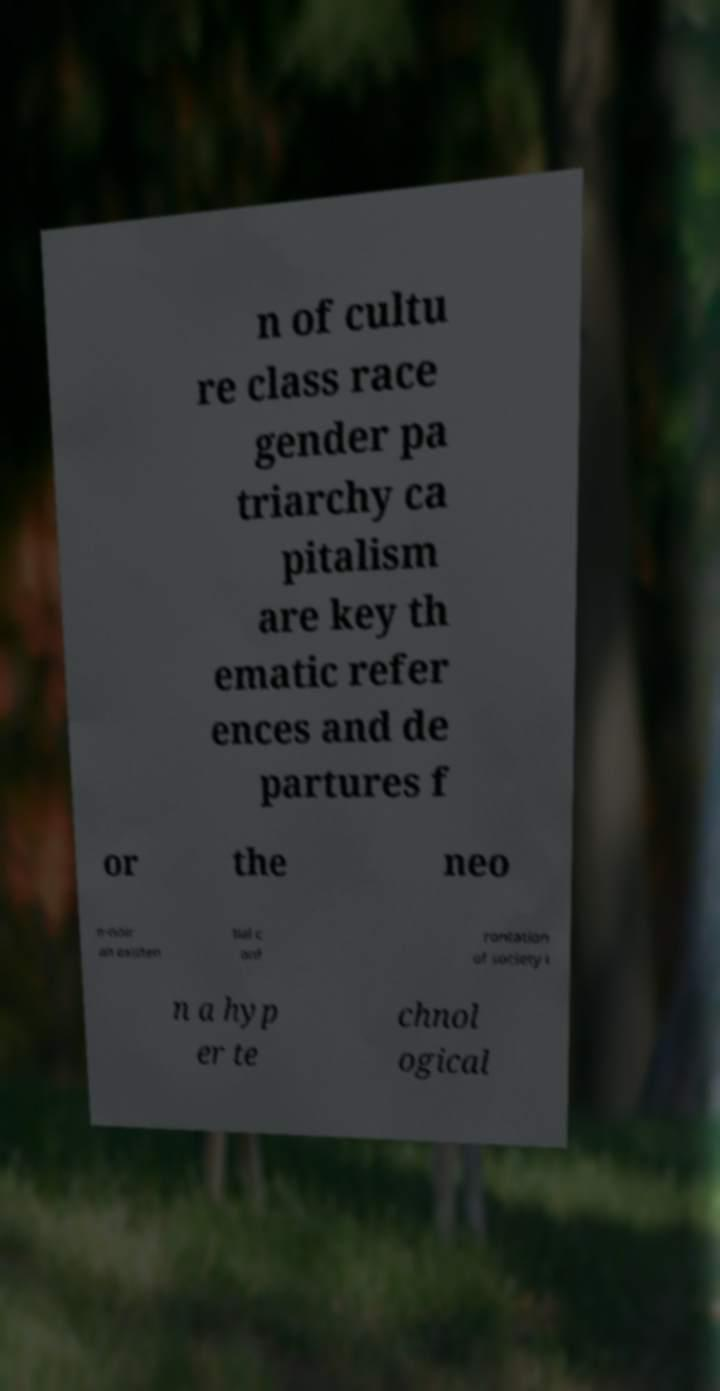Can you read and provide the text displayed in the image?This photo seems to have some interesting text. Can you extract and type it out for me? n of cultu re class race gender pa triarchy ca pitalism are key th ematic refer ences and de partures f or the neo n-noir an existen tial c onf rontation of society i n a hyp er te chnol ogical 